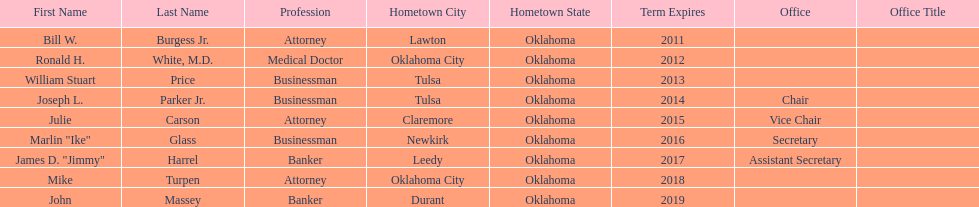How many of the current state regents have a listed office title? 4. 